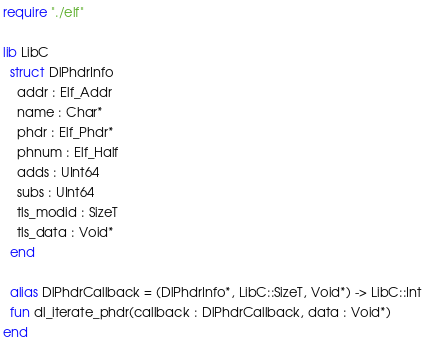<code> <loc_0><loc_0><loc_500><loc_500><_Crystal_>require "./elf"

lib LibC
  struct DlPhdrInfo
    addr : Elf_Addr
    name : Char*
    phdr : Elf_Phdr*
    phnum : Elf_Half
    adds : UInt64
    subs : UInt64
    tls_modid : SizeT
    tls_data : Void*
  end

  alias DlPhdrCallback = (DlPhdrInfo*, LibC::SizeT, Void*) -> LibC::Int
  fun dl_iterate_phdr(callback : DlPhdrCallback, data : Void*)
end
</code> 